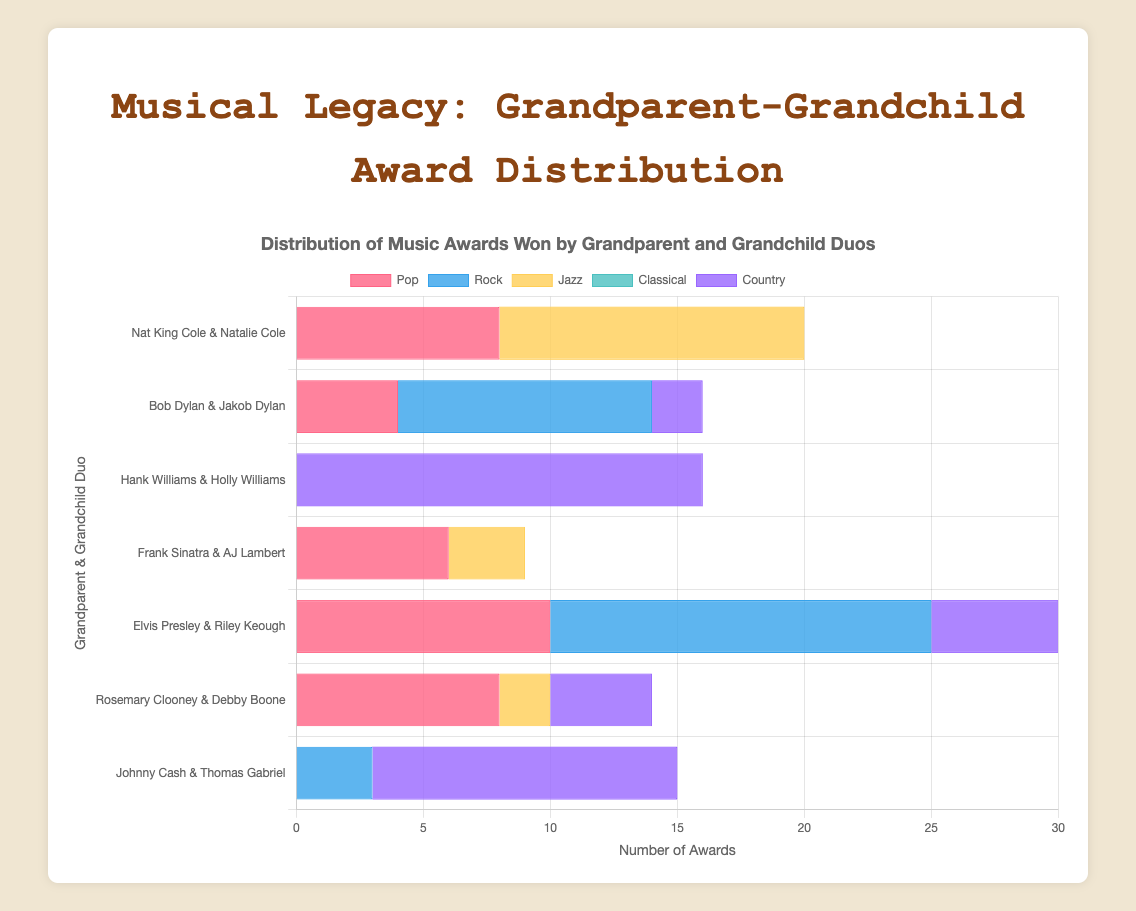Which duo has won the most awards in the Jazz category? Look for the duo with the tallest bars in the Jazz category. Nat King Cole & Natalie Cole have the highest measurement in the Jazz category with 12 awards.
Answer: Nat King Cole & Natalie Cole Who has more awards in the Country category, Hank Williams & Holly Williams or Johnny Cash & Thomas Gabriel? Compare the height of the bars for Hank Williams & Holly Williams and Johnny Cash & Thomas Gabriel in the Country category. Hank Williams & Holly Williams have 16 awards while Johnny Cash & Thomas Gabriel have 12.
Answer: Hank Williams & Holly Williams What is the total number of awards won by Rosemary Clooney & Debby Boone in all categories? Sum up the bars for each category for Rosemary Clooney & Debby Boone (8 Pop, 0 Rock, 2 Jazz, 0 Classical, and 4 Country).
Answer: 14 Which category has the least awards for Bob Dylan & Jakob Dylan? Identify the category with the shortest bars (or zero) for Bob Dylan & Jakob Dylan. They have 0 awards in the Jazz and Classical categories.
Answer: Jazz and Classical How many more awards does Bob Dylan & Jakob Dylan have in the Rock category compared to the Country category? Subtract the awards in the Country category from the Rock category for Bob Dylan & Jakob Dylan (10 Rock - 2 Country).
Answer: 8 What is the average number of Pop awards won by the listed duos? Add the Pop awards for all duos (8, 4, 0, 6, 10, 8, 0), and then divide by the number of duos (7).
Answer: 5.14 Which duo has a more diverse range of awards (earned awards in more categories), Elvis Presley & Riley Keough or Frank Sinatra & AJ Lambert? Check the number of categories each duo has awards in. Elvis Presley & Riley Keough have awards in Pop, Rock, and Country categories (3), while Frank Sinatra & AJ Lambert have awards in Pop and Jazz categories (2).
Answer: Elvis Presley & Riley Keough In the Pop category, who has won more awards, Nat King Cole & Natalie Cole or Frank Sinatra & AJ Lambert? Compare the heights of the bars in the Pop category. Nat King Cole & Natalie Cole have won 8 awards, while Frank Sinatra & AJ Lambert have won 6 awards.
Answer: Nat King Cole & Natalie Cole What is the most significant difference in the number of awards between grandparent and grandchild duos in the Jazz category? Identify all the awards in the Jazz category and find the highest difference between any two duos. Nat King Cole & Natalie Cole have 12, Frank Sinatra & AJ Lambert have 3, and Rosemary Clooney & Debby Boone have 2. The difference between Nat King Cole & Natalie Cole and the next highest (Frank Sinatra & AJ Lambert) is 12 - 3 = 9.
Answer: 9 Which category shows the highest total number of awards across all duos? Sum up the awards across all duos for each category (Pop, Rock, Jazz, Classical, Country) and determine the highest total.
Answer: Pop 